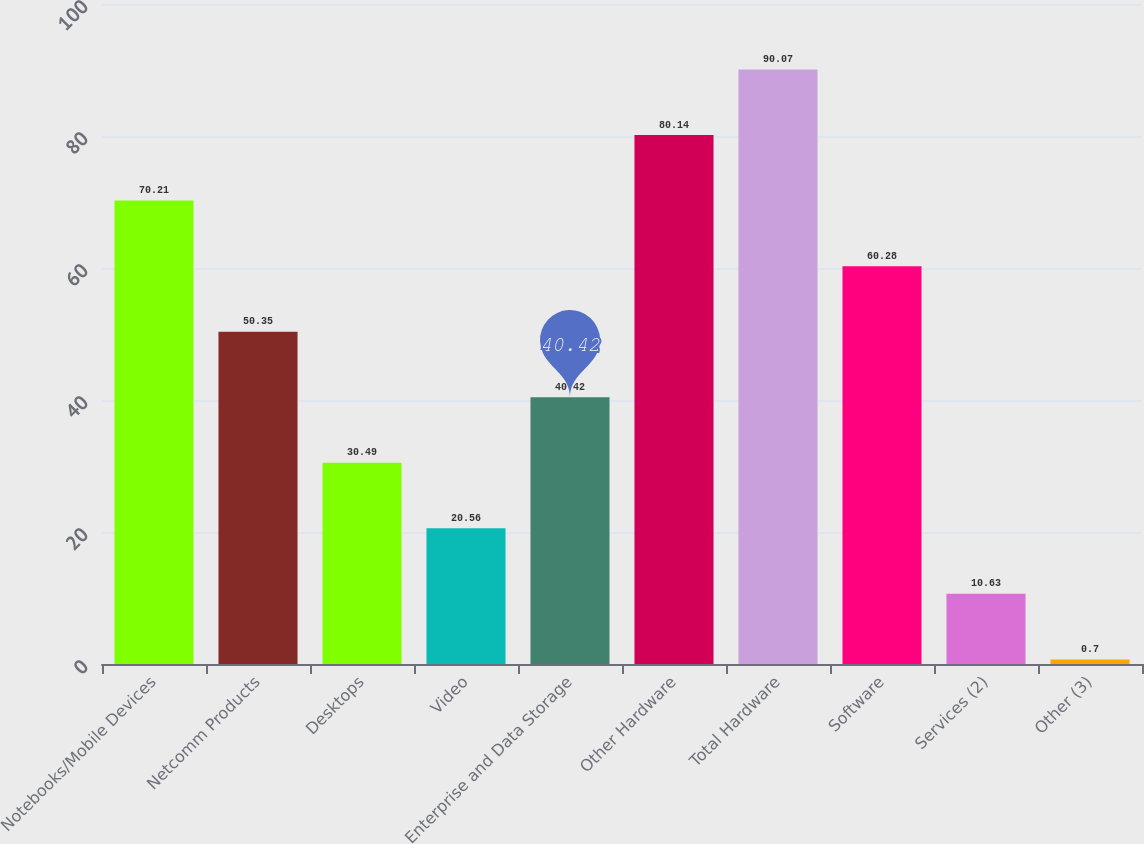Convert chart. <chart><loc_0><loc_0><loc_500><loc_500><bar_chart><fcel>Notebooks/Mobile Devices<fcel>Netcomm Products<fcel>Desktops<fcel>Video<fcel>Enterprise and Data Storage<fcel>Other Hardware<fcel>Total Hardware<fcel>Software<fcel>Services (2)<fcel>Other (3)<nl><fcel>70.21<fcel>50.35<fcel>30.49<fcel>20.56<fcel>40.42<fcel>80.14<fcel>90.07<fcel>60.28<fcel>10.63<fcel>0.7<nl></chart> 